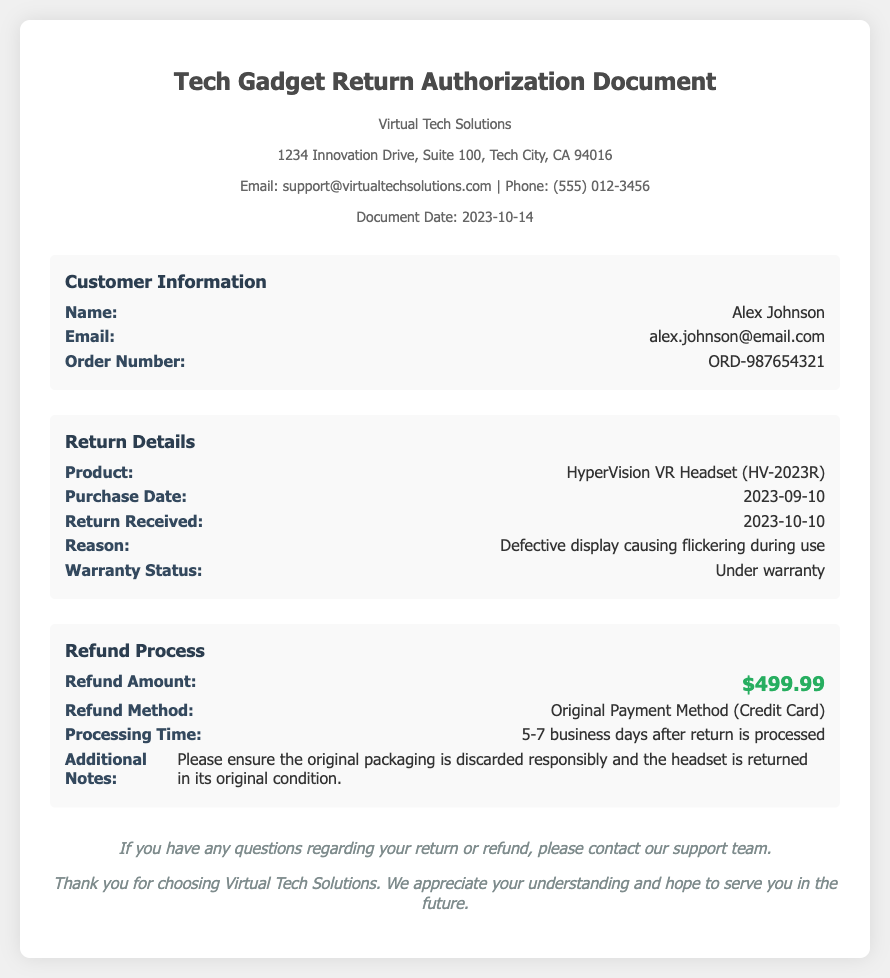What is the customer's name? The customer's name is provided in the customer information section of the document.
Answer: Alex Johnson What was the reason for the return? The reason for return is specified in the return details section of the document.
Answer: Defective display causing flickering during use What is the purchase date of the VR headset? The purchase date can be found in the return details section.
Answer: 2023-09-10 What is the refund amount? The refund amount is stated in the refund process section of the document.
Answer: $499.99 What is the processing time for the refund? The processing time is mentioned in the refund process section of the document.
Answer: 5-7 business days after return is processed What is the warranty status of the product? The warranty status is listed in the return details section of the document.
Answer: Under warranty What method will the refund be issued? The method for the refund is specified in the refund process section.
Answer: Original Payment Method (Credit Card) When was the return received? The date the return was received can be found in the return details section.
Answer: 2023-10-10 What is the company name? The company name is located in the header of the document.
Answer: Virtual Tech Solutions 